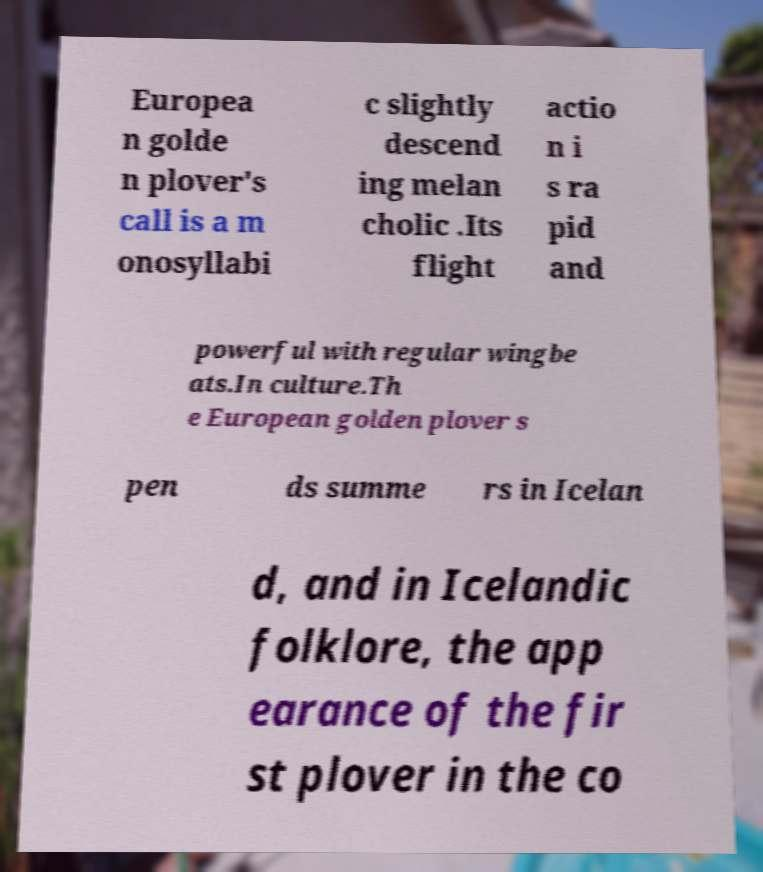Could you assist in decoding the text presented in this image and type it out clearly? Europea n golde n plover's call is a m onosyllabi c slightly descend ing melan cholic .Its flight actio n i s ra pid and powerful with regular wingbe ats.In culture.Th e European golden plover s pen ds summe rs in Icelan d, and in Icelandic folklore, the app earance of the fir st plover in the co 